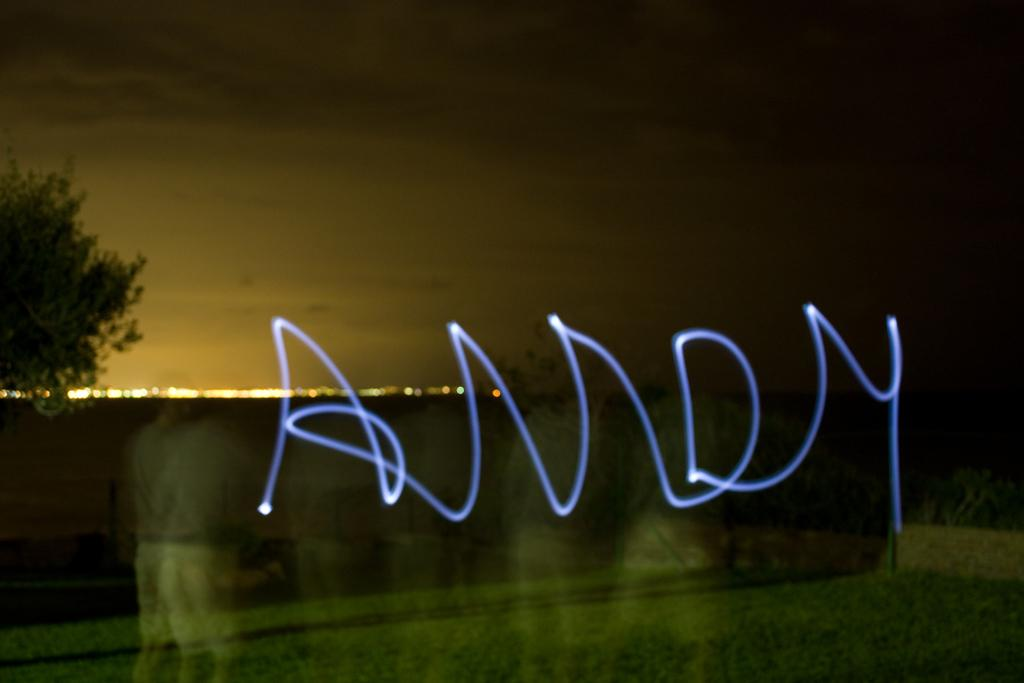What object is present in the image that is typically used for holding liquids? There is a glass in the image. What type of natural element can be seen on the left side of the image? There is a tree on the left side of the image. What can be seen in the background of the image that provides illumination? There are lights visible in the background of the image. What part of the environment is visible in the background of the image? The sky is visible in the background of the image. What type of skin condition is visible on the tree in the image? There is no skin condition present on the tree in the image, as trees do not have skin. 